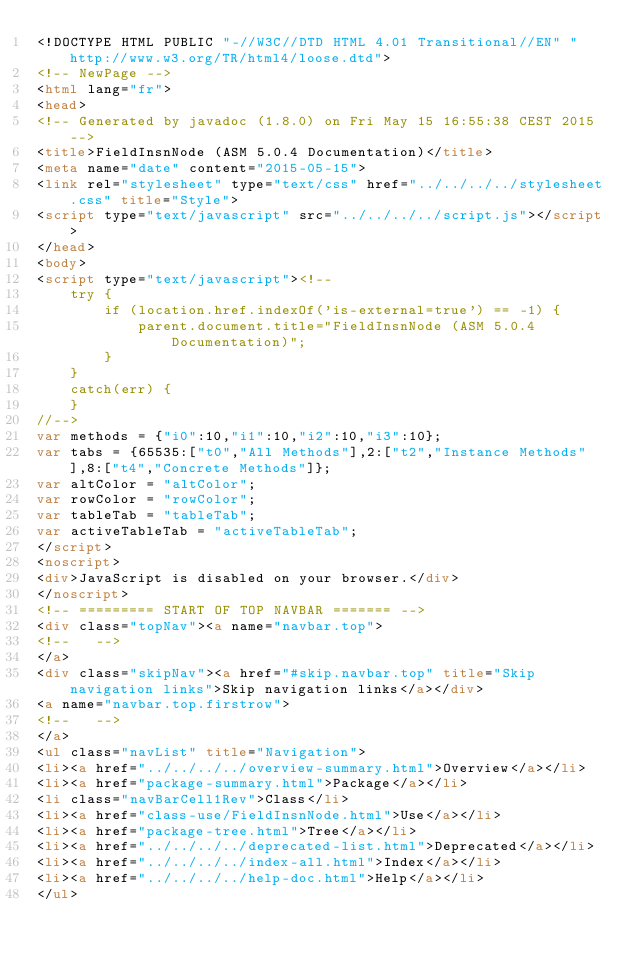<code> <loc_0><loc_0><loc_500><loc_500><_HTML_><!DOCTYPE HTML PUBLIC "-//W3C//DTD HTML 4.01 Transitional//EN" "http://www.w3.org/TR/html4/loose.dtd">
<!-- NewPage -->
<html lang="fr">
<head>
<!-- Generated by javadoc (1.8.0) on Fri May 15 16:55:38 CEST 2015 -->
<title>FieldInsnNode (ASM 5.0.4 Documentation)</title>
<meta name="date" content="2015-05-15">
<link rel="stylesheet" type="text/css" href="../../../../stylesheet.css" title="Style">
<script type="text/javascript" src="../../../../script.js"></script>
</head>
<body>
<script type="text/javascript"><!--
    try {
        if (location.href.indexOf('is-external=true') == -1) {
            parent.document.title="FieldInsnNode (ASM 5.0.4 Documentation)";
        }
    }
    catch(err) {
    }
//-->
var methods = {"i0":10,"i1":10,"i2":10,"i3":10};
var tabs = {65535:["t0","All Methods"],2:["t2","Instance Methods"],8:["t4","Concrete Methods"]};
var altColor = "altColor";
var rowColor = "rowColor";
var tableTab = "tableTab";
var activeTableTab = "activeTableTab";
</script>
<noscript>
<div>JavaScript is disabled on your browser.</div>
</noscript>
<!-- ========= START OF TOP NAVBAR ======= -->
<div class="topNav"><a name="navbar.top">
<!--   -->
</a>
<div class="skipNav"><a href="#skip.navbar.top" title="Skip navigation links">Skip navigation links</a></div>
<a name="navbar.top.firstrow">
<!--   -->
</a>
<ul class="navList" title="Navigation">
<li><a href="../../../../overview-summary.html">Overview</a></li>
<li><a href="package-summary.html">Package</a></li>
<li class="navBarCell1Rev">Class</li>
<li><a href="class-use/FieldInsnNode.html">Use</a></li>
<li><a href="package-tree.html">Tree</a></li>
<li><a href="../../../../deprecated-list.html">Deprecated</a></li>
<li><a href="../../../../index-all.html">Index</a></li>
<li><a href="../../../../help-doc.html">Help</a></li>
</ul></code> 